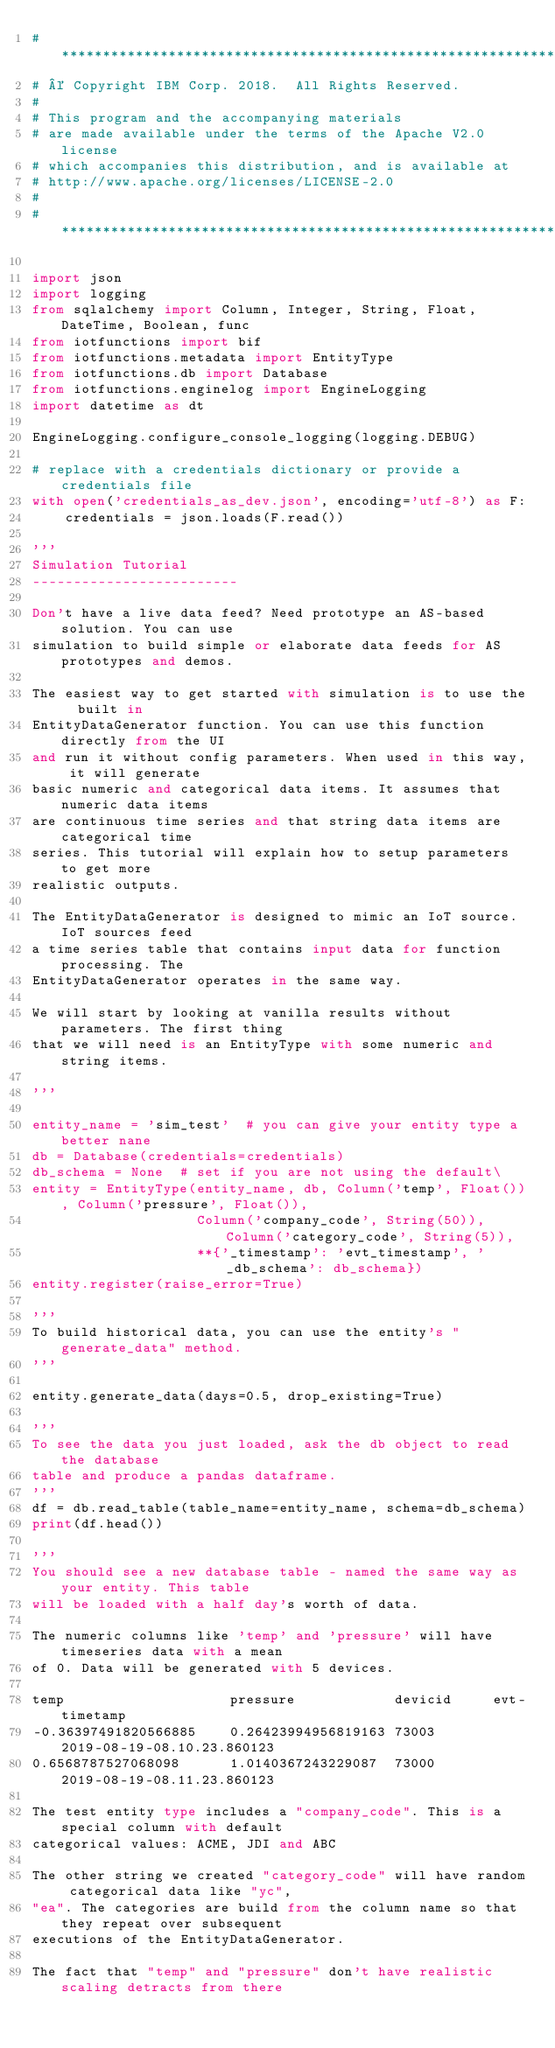<code> <loc_0><loc_0><loc_500><loc_500><_Python_># *****************************************************************************
# © Copyright IBM Corp. 2018.  All Rights Reserved.
#
# This program and the accompanying materials
# are made available under the terms of the Apache V2.0 license
# which accompanies this distribution, and is available at
# http://www.apache.org/licenses/LICENSE-2.0
#
# *****************************************************************************

import json
import logging
from sqlalchemy import Column, Integer, String, Float, DateTime, Boolean, func
from iotfunctions import bif
from iotfunctions.metadata import EntityType
from iotfunctions.db import Database
from iotfunctions.enginelog import EngineLogging
import datetime as dt

EngineLogging.configure_console_logging(logging.DEBUG)

# replace with a credentials dictionary or provide a credentials file
with open('credentials_as_dev.json', encoding='utf-8') as F:
    credentials = json.loads(F.read())

'''
Simulation Tutorial
-------------------------

Don't have a live data feed? Need prototype an AS-based solution. You can use
simulation to build simple or elaborate data feeds for AS prototypes and demos.

The easiest way to get started with simulation is to use the  built in 
EntityDataGenerator function. You can use this function directly from the UI
and run it without config parameters. When used in this way, it will generate
basic numeric and categorical data items. It assumes that numeric data items
are continuous time series and that string data items are categorical time 
series. This tutorial will explain how to setup parameters to get more
realistic outputs.

The EntityDataGenerator is designed to mimic an IoT source. IoT sources feed
a time series table that contains input data for function processing. The
EntityDataGenerator operates in the same way.

We will start by looking at vanilla results without parameters. The first thing
that we will need is an EntityType with some numeric and string items.  

'''

entity_name = 'sim_test'  # you can give your entity type a better nane
db = Database(credentials=credentials)
db_schema = None  # set if you are not using the default\
entity = EntityType(entity_name, db, Column('temp', Float()), Column('pressure', Float()),
                    Column('company_code', String(50)), Column('category_code', String(5)),
                    **{'_timestamp': 'evt_timestamp', '_db_schema': db_schema})
entity.register(raise_error=True)

'''
To build historical data, you can use the entity's "generate_data" method.
'''

entity.generate_data(days=0.5, drop_existing=True)

'''
To see the data you just loaded, ask the db object to read the database
table and produce a pandas dataframe.
'''
df = db.read_table(table_name=entity_name, schema=db_schema)
print(df.head())

'''
You should see a new database table - named the same way as your entity. This table
will be loaded with a half day's worth of data.

The numeric columns like 'temp' and 'pressure' will have timeseries data with a mean
of 0. Data will be generated with 5 devices.

temp                    pressure            devicid     evt-timetamp
-0.36397491820566885	0.26423994956819163	73003	    2019-08-19-08.10.23.860123
0.6568787527068098	    1.0140367243229087	73000	    2019-08-19-08.11.23.860123

The test entity type includes a "company_code". This is a special column with default
categorical values: ACME, JDI and ABC

The other string we created "category_code" will have random categorical data like "yc",
"ea". The categories are build from the column name so that they repeat over subsequent
executions of the EntityDataGenerator.

The fact that "temp" and "pressure" don't have realistic scaling detracts from there</code> 